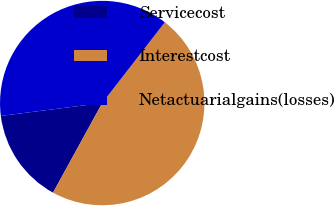Convert chart to OTSL. <chart><loc_0><loc_0><loc_500><loc_500><pie_chart><fcel>Servicecost<fcel>Interestcost<fcel>Netactuarialgains(losses)<nl><fcel>15.0%<fcel>47.5%<fcel>37.5%<nl></chart> 